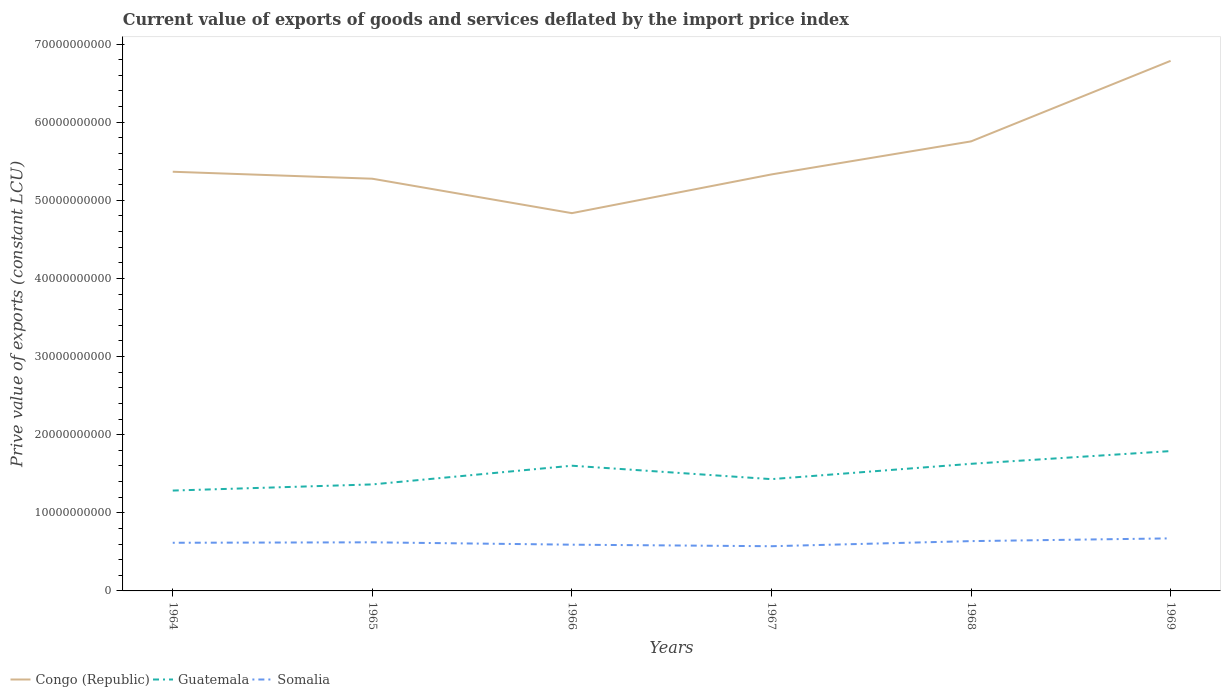Is the number of lines equal to the number of legend labels?
Offer a terse response. Yes. Across all years, what is the maximum prive value of exports in Somalia?
Keep it short and to the point. 5.72e+09. In which year was the prive value of exports in Congo (Republic) maximum?
Offer a terse response. 1966. What is the total prive value of exports in Congo (Republic) in the graph?
Your answer should be compact. -1.42e+1. What is the difference between the highest and the second highest prive value of exports in Guatemala?
Provide a short and direct response. 5.06e+09. What is the difference between the highest and the lowest prive value of exports in Guatemala?
Your answer should be compact. 3. How many lines are there?
Provide a short and direct response. 3. What is the difference between two consecutive major ticks on the Y-axis?
Provide a short and direct response. 1.00e+1. Are the values on the major ticks of Y-axis written in scientific E-notation?
Your response must be concise. No. Does the graph contain any zero values?
Provide a short and direct response. No. Where does the legend appear in the graph?
Ensure brevity in your answer.  Bottom left. How many legend labels are there?
Your answer should be compact. 3. What is the title of the graph?
Give a very brief answer. Current value of exports of goods and services deflated by the import price index. What is the label or title of the X-axis?
Offer a terse response. Years. What is the label or title of the Y-axis?
Make the answer very short. Prive value of exports (constant LCU). What is the Prive value of exports (constant LCU) of Congo (Republic) in 1964?
Your answer should be compact. 5.37e+1. What is the Prive value of exports (constant LCU) in Guatemala in 1964?
Your response must be concise. 1.28e+1. What is the Prive value of exports (constant LCU) in Somalia in 1964?
Ensure brevity in your answer.  6.16e+09. What is the Prive value of exports (constant LCU) in Congo (Republic) in 1965?
Provide a succinct answer. 5.28e+1. What is the Prive value of exports (constant LCU) in Guatemala in 1965?
Make the answer very short. 1.36e+1. What is the Prive value of exports (constant LCU) in Somalia in 1965?
Your answer should be compact. 6.22e+09. What is the Prive value of exports (constant LCU) in Congo (Republic) in 1966?
Give a very brief answer. 4.84e+1. What is the Prive value of exports (constant LCU) of Guatemala in 1966?
Provide a succinct answer. 1.60e+1. What is the Prive value of exports (constant LCU) in Somalia in 1966?
Give a very brief answer. 5.92e+09. What is the Prive value of exports (constant LCU) in Congo (Republic) in 1967?
Offer a very short reply. 5.33e+1. What is the Prive value of exports (constant LCU) in Guatemala in 1967?
Make the answer very short. 1.43e+1. What is the Prive value of exports (constant LCU) of Somalia in 1967?
Your response must be concise. 5.72e+09. What is the Prive value of exports (constant LCU) in Congo (Republic) in 1968?
Offer a very short reply. 5.75e+1. What is the Prive value of exports (constant LCU) of Guatemala in 1968?
Make the answer very short. 1.63e+1. What is the Prive value of exports (constant LCU) in Somalia in 1968?
Offer a very short reply. 6.37e+09. What is the Prive value of exports (constant LCU) of Congo (Republic) in 1969?
Your response must be concise. 6.78e+1. What is the Prive value of exports (constant LCU) of Guatemala in 1969?
Offer a very short reply. 1.79e+1. What is the Prive value of exports (constant LCU) of Somalia in 1969?
Your answer should be very brief. 6.73e+09. Across all years, what is the maximum Prive value of exports (constant LCU) of Congo (Republic)?
Ensure brevity in your answer.  6.78e+1. Across all years, what is the maximum Prive value of exports (constant LCU) in Guatemala?
Ensure brevity in your answer.  1.79e+1. Across all years, what is the maximum Prive value of exports (constant LCU) in Somalia?
Give a very brief answer. 6.73e+09. Across all years, what is the minimum Prive value of exports (constant LCU) in Congo (Republic)?
Offer a very short reply. 4.84e+1. Across all years, what is the minimum Prive value of exports (constant LCU) in Guatemala?
Your answer should be very brief. 1.28e+1. Across all years, what is the minimum Prive value of exports (constant LCU) in Somalia?
Provide a succinct answer. 5.72e+09. What is the total Prive value of exports (constant LCU) of Congo (Republic) in the graph?
Offer a very short reply. 3.33e+11. What is the total Prive value of exports (constant LCU) of Guatemala in the graph?
Your response must be concise. 9.10e+1. What is the total Prive value of exports (constant LCU) in Somalia in the graph?
Make the answer very short. 3.71e+1. What is the difference between the Prive value of exports (constant LCU) in Congo (Republic) in 1964 and that in 1965?
Provide a short and direct response. 8.94e+08. What is the difference between the Prive value of exports (constant LCU) of Guatemala in 1964 and that in 1965?
Provide a short and direct response. -7.87e+08. What is the difference between the Prive value of exports (constant LCU) of Somalia in 1964 and that in 1965?
Your answer should be very brief. -5.68e+07. What is the difference between the Prive value of exports (constant LCU) of Congo (Republic) in 1964 and that in 1966?
Provide a succinct answer. 5.30e+09. What is the difference between the Prive value of exports (constant LCU) in Guatemala in 1964 and that in 1966?
Provide a succinct answer. -3.18e+09. What is the difference between the Prive value of exports (constant LCU) of Somalia in 1964 and that in 1966?
Offer a very short reply. 2.45e+08. What is the difference between the Prive value of exports (constant LCU) in Congo (Republic) in 1964 and that in 1967?
Keep it short and to the point. 3.43e+08. What is the difference between the Prive value of exports (constant LCU) of Guatemala in 1964 and that in 1967?
Ensure brevity in your answer.  -1.46e+09. What is the difference between the Prive value of exports (constant LCU) of Somalia in 1964 and that in 1967?
Provide a short and direct response. 4.42e+08. What is the difference between the Prive value of exports (constant LCU) in Congo (Republic) in 1964 and that in 1968?
Offer a terse response. -3.89e+09. What is the difference between the Prive value of exports (constant LCU) of Guatemala in 1964 and that in 1968?
Your answer should be compact. -3.42e+09. What is the difference between the Prive value of exports (constant LCU) of Somalia in 1964 and that in 1968?
Your answer should be very brief. -2.11e+08. What is the difference between the Prive value of exports (constant LCU) in Congo (Republic) in 1964 and that in 1969?
Your response must be concise. -1.42e+1. What is the difference between the Prive value of exports (constant LCU) in Guatemala in 1964 and that in 1969?
Ensure brevity in your answer.  -5.06e+09. What is the difference between the Prive value of exports (constant LCU) of Somalia in 1964 and that in 1969?
Offer a terse response. -5.62e+08. What is the difference between the Prive value of exports (constant LCU) in Congo (Republic) in 1965 and that in 1966?
Your response must be concise. 4.41e+09. What is the difference between the Prive value of exports (constant LCU) in Guatemala in 1965 and that in 1966?
Ensure brevity in your answer.  -2.39e+09. What is the difference between the Prive value of exports (constant LCU) in Somalia in 1965 and that in 1966?
Provide a succinct answer. 3.02e+08. What is the difference between the Prive value of exports (constant LCU) of Congo (Republic) in 1965 and that in 1967?
Offer a very short reply. -5.51e+08. What is the difference between the Prive value of exports (constant LCU) of Guatemala in 1965 and that in 1967?
Give a very brief answer. -6.75e+08. What is the difference between the Prive value of exports (constant LCU) in Somalia in 1965 and that in 1967?
Your answer should be very brief. 4.99e+08. What is the difference between the Prive value of exports (constant LCU) in Congo (Republic) in 1965 and that in 1968?
Make the answer very short. -4.78e+09. What is the difference between the Prive value of exports (constant LCU) of Guatemala in 1965 and that in 1968?
Provide a succinct answer. -2.64e+09. What is the difference between the Prive value of exports (constant LCU) in Somalia in 1965 and that in 1968?
Provide a succinct answer. -1.54e+08. What is the difference between the Prive value of exports (constant LCU) in Congo (Republic) in 1965 and that in 1969?
Offer a very short reply. -1.51e+1. What is the difference between the Prive value of exports (constant LCU) of Guatemala in 1965 and that in 1969?
Ensure brevity in your answer.  -4.27e+09. What is the difference between the Prive value of exports (constant LCU) of Somalia in 1965 and that in 1969?
Provide a short and direct response. -5.06e+08. What is the difference between the Prive value of exports (constant LCU) in Congo (Republic) in 1966 and that in 1967?
Ensure brevity in your answer.  -4.96e+09. What is the difference between the Prive value of exports (constant LCU) in Guatemala in 1966 and that in 1967?
Offer a terse response. 1.72e+09. What is the difference between the Prive value of exports (constant LCU) in Somalia in 1966 and that in 1967?
Give a very brief answer. 1.97e+08. What is the difference between the Prive value of exports (constant LCU) of Congo (Republic) in 1966 and that in 1968?
Your response must be concise. -9.19e+09. What is the difference between the Prive value of exports (constant LCU) of Guatemala in 1966 and that in 1968?
Make the answer very short. -2.43e+08. What is the difference between the Prive value of exports (constant LCU) in Somalia in 1966 and that in 1968?
Make the answer very short. -4.56e+08. What is the difference between the Prive value of exports (constant LCU) in Congo (Republic) in 1966 and that in 1969?
Your response must be concise. -1.95e+1. What is the difference between the Prive value of exports (constant LCU) in Guatemala in 1966 and that in 1969?
Ensure brevity in your answer.  -1.87e+09. What is the difference between the Prive value of exports (constant LCU) in Somalia in 1966 and that in 1969?
Your answer should be very brief. -8.08e+08. What is the difference between the Prive value of exports (constant LCU) in Congo (Republic) in 1967 and that in 1968?
Your answer should be compact. -4.23e+09. What is the difference between the Prive value of exports (constant LCU) in Guatemala in 1967 and that in 1968?
Provide a short and direct response. -1.96e+09. What is the difference between the Prive value of exports (constant LCU) of Somalia in 1967 and that in 1968?
Your answer should be very brief. -6.53e+08. What is the difference between the Prive value of exports (constant LCU) in Congo (Republic) in 1967 and that in 1969?
Offer a very short reply. -1.45e+1. What is the difference between the Prive value of exports (constant LCU) in Guatemala in 1967 and that in 1969?
Give a very brief answer. -3.59e+09. What is the difference between the Prive value of exports (constant LCU) in Somalia in 1967 and that in 1969?
Keep it short and to the point. -1.00e+09. What is the difference between the Prive value of exports (constant LCU) of Congo (Republic) in 1968 and that in 1969?
Provide a succinct answer. -1.03e+1. What is the difference between the Prive value of exports (constant LCU) of Guatemala in 1968 and that in 1969?
Make the answer very short. -1.63e+09. What is the difference between the Prive value of exports (constant LCU) of Somalia in 1968 and that in 1969?
Offer a terse response. -3.52e+08. What is the difference between the Prive value of exports (constant LCU) in Congo (Republic) in 1964 and the Prive value of exports (constant LCU) in Guatemala in 1965?
Keep it short and to the point. 4.00e+1. What is the difference between the Prive value of exports (constant LCU) of Congo (Republic) in 1964 and the Prive value of exports (constant LCU) of Somalia in 1965?
Your answer should be compact. 4.74e+1. What is the difference between the Prive value of exports (constant LCU) in Guatemala in 1964 and the Prive value of exports (constant LCU) in Somalia in 1965?
Keep it short and to the point. 6.63e+09. What is the difference between the Prive value of exports (constant LCU) in Congo (Republic) in 1964 and the Prive value of exports (constant LCU) in Guatemala in 1966?
Offer a terse response. 3.76e+1. What is the difference between the Prive value of exports (constant LCU) in Congo (Republic) in 1964 and the Prive value of exports (constant LCU) in Somalia in 1966?
Your answer should be compact. 4.77e+1. What is the difference between the Prive value of exports (constant LCU) of Guatemala in 1964 and the Prive value of exports (constant LCU) of Somalia in 1966?
Make the answer very short. 6.93e+09. What is the difference between the Prive value of exports (constant LCU) in Congo (Republic) in 1964 and the Prive value of exports (constant LCU) in Guatemala in 1967?
Your answer should be very brief. 3.93e+1. What is the difference between the Prive value of exports (constant LCU) of Congo (Republic) in 1964 and the Prive value of exports (constant LCU) of Somalia in 1967?
Offer a very short reply. 4.79e+1. What is the difference between the Prive value of exports (constant LCU) of Guatemala in 1964 and the Prive value of exports (constant LCU) of Somalia in 1967?
Your answer should be compact. 7.12e+09. What is the difference between the Prive value of exports (constant LCU) in Congo (Republic) in 1964 and the Prive value of exports (constant LCU) in Guatemala in 1968?
Offer a very short reply. 3.74e+1. What is the difference between the Prive value of exports (constant LCU) in Congo (Republic) in 1964 and the Prive value of exports (constant LCU) in Somalia in 1968?
Ensure brevity in your answer.  4.73e+1. What is the difference between the Prive value of exports (constant LCU) of Guatemala in 1964 and the Prive value of exports (constant LCU) of Somalia in 1968?
Provide a succinct answer. 6.47e+09. What is the difference between the Prive value of exports (constant LCU) of Congo (Republic) in 1964 and the Prive value of exports (constant LCU) of Guatemala in 1969?
Provide a succinct answer. 3.58e+1. What is the difference between the Prive value of exports (constant LCU) in Congo (Republic) in 1964 and the Prive value of exports (constant LCU) in Somalia in 1969?
Ensure brevity in your answer.  4.69e+1. What is the difference between the Prive value of exports (constant LCU) of Guatemala in 1964 and the Prive value of exports (constant LCU) of Somalia in 1969?
Your answer should be very brief. 6.12e+09. What is the difference between the Prive value of exports (constant LCU) in Congo (Republic) in 1965 and the Prive value of exports (constant LCU) in Guatemala in 1966?
Provide a short and direct response. 3.67e+1. What is the difference between the Prive value of exports (constant LCU) in Congo (Republic) in 1965 and the Prive value of exports (constant LCU) in Somalia in 1966?
Ensure brevity in your answer.  4.68e+1. What is the difference between the Prive value of exports (constant LCU) in Guatemala in 1965 and the Prive value of exports (constant LCU) in Somalia in 1966?
Give a very brief answer. 7.71e+09. What is the difference between the Prive value of exports (constant LCU) in Congo (Republic) in 1965 and the Prive value of exports (constant LCU) in Guatemala in 1967?
Offer a very short reply. 3.85e+1. What is the difference between the Prive value of exports (constant LCU) in Congo (Republic) in 1965 and the Prive value of exports (constant LCU) in Somalia in 1967?
Provide a short and direct response. 4.70e+1. What is the difference between the Prive value of exports (constant LCU) of Guatemala in 1965 and the Prive value of exports (constant LCU) of Somalia in 1967?
Provide a short and direct response. 7.91e+09. What is the difference between the Prive value of exports (constant LCU) in Congo (Republic) in 1965 and the Prive value of exports (constant LCU) in Guatemala in 1968?
Your response must be concise. 3.65e+1. What is the difference between the Prive value of exports (constant LCU) of Congo (Republic) in 1965 and the Prive value of exports (constant LCU) of Somalia in 1968?
Your answer should be compact. 4.64e+1. What is the difference between the Prive value of exports (constant LCU) of Guatemala in 1965 and the Prive value of exports (constant LCU) of Somalia in 1968?
Provide a succinct answer. 7.26e+09. What is the difference between the Prive value of exports (constant LCU) of Congo (Republic) in 1965 and the Prive value of exports (constant LCU) of Guatemala in 1969?
Your answer should be compact. 3.49e+1. What is the difference between the Prive value of exports (constant LCU) of Congo (Republic) in 1965 and the Prive value of exports (constant LCU) of Somalia in 1969?
Your answer should be compact. 4.60e+1. What is the difference between the Prive value of exports (constant LCU) of Guatemala in 1965 and the Prive value of exports (constant LCU) of Somalia in 1969?
Offer a terse response. 6.91e+09. What is the difference between the Prive value of exports (constant LCU) in Congo (Republic) in 1966 and the Prive value of exports (constant LCU) in Guatemala in 1967?
Ensure brevity in your answer.  3.40e+1. What is the difference between the Prive value of exports (constant LCU) of Congo (Republic) in 1966 and the Prive value of exports (constant LCU) of Somalia in 1967?
Ensure brevity in your answer.  4.26e+1. What is the difference between the Prive value of exports (constant LCU) in Guatemala in 1966 and the Prive value of exports (constant LCU) in Somalia in 1967?
Offer a terse response. 1.03e+1. What is the difference between the Prive value of exports (constant LCU) of Congo (Republic) in 1966 and the Prive value of exports (constant LCU) of Guatemala in 1968?
Offer a terse response. 3.21e+1. What is the difference between the Prive value of exports (constant LCU) of Congo (Republic) in 1966 and the Prive value of exports (constant LCU) of Somalia in 1968?
Offer a terse response. 4.20e+1. What is the difference between the Prive value of exports (constant LCU) in Guatemala in 1966 and the Prive value of exports (constant LCU) in Somalia in 1968?
Your answer should be very brief. 9.65e+09. What is the difference between the Prive value of exports (constant LCU) of Congo (Republic) in 1966 and the Prive value of exports (constant LCU) of Guatemala in 1969?
Keep it short and to the point. 3.05e+1. What is the difference between the Prive value of exports (constant LCU) of Congo (Republic) in 1966 and the Prive value of exports (constant LCU) of Somalia in 1969?
Make the answer very short. 4.16e+1. What is the difference between the Prive value of exports (constant LCU) in Guatemala in 1966 and the Prive value of exports (constant LCU) in Somalia in 1969?
Your answer should be very brief. 9.30e+09. What is the difference between the Prive value of exports (constant LCU) of Congo (Republic) in 1967 and the Prive value of exports (constant LCU) of Guatemala in 1968?
Provide a short and direct response. 3.70e+1. What is the difference between the Prive value of exports (constant LCU) in Congo (Republic) in 1967 and the Prive value of exports (constant LCU) in Somalia in 1968?
Ensure brevity in your answer.  4.69e+1. What is the difference between the Prive value of exports (constant LCU) of Guatemala in 1967 and the Prive value of exports (constant LCU) of Somalia in 1968?
Ensure brevity in your answer.  7.93e+09. What is the difference between the Prive value of exports (constant LCU) in Congo (Republic) in 1967 and the Prive value of exports (constant LCU) in Guatemala in 1969?
Make the answer very short. 3.54e+1. What is the difference between the Prive value of exports (constant LCU) of Congo (Republic) in 1967 and the Prive value of exports (constant LCU) of Somalia in 1969?
Offer a very short reply. 4.66e+1. What is the difference between the Prive value of exports (constant LCU) in Guatemala in 1967 and the Prive value of exports (constant LCU) in Somalia in 1969?
Make the answer very short. 7.58e+09. What is the difference between the Prive value of exports (constant LCU) in Congo (Republic) in 1968 and the Prive value of exports (constant LCU) in Guatemala in 1969?
Make the answer very short. 3.96e+1. What is the difference between the Prive value of exports (constant LCU) of Congo (Republic) in 1968 and the Prive value of exports (constant LCU) of Somalia in 1969?
Ensure brevity in your answer.  5.08e+1. What is the difference between the Prive value of exports (constant LCU) in Guatemala in 1968 and the Prive value of exports (constant LCU) in Somalia in 1969?
Your answer should be very brief. 9.54e+09. What is the average Prive value of exports (constant LCU) of Congo (Republic) per year?
Offer a terse response. 5.56e+1. What is the average Prive value of exports (constant LCU) of Guatemala per year?
Give a very brief answer. 1.52e+1. What is the average Prive value of exports (constant LCU) in Somalia per year?
Offer a very short reply. 6.19e+09. In the year 1964, what is the difference between the Prive value of exports (constant LCU) of Congo (Republic) and Prive value of exports (constant LCU) of Guatemala?
Provide a short and direct response. 4.08e+1. In the year 1964, what is the difference between the Prive value of exports (constant LCU) of Congo (Republic) and Prive value of exports (constant LCU) of Somalia?
Give a very brief answer. 4.75e+1. In the year 1964, what is the difference between the Prive value of exports (constant LCU) in Guatemala and Prive value of exports (constant LCU) in Somalia?
Make the answer very short. 6.68e+09. In the year 1965, what is the difference between the Prive value of exports (constant LCU) of Congo (Republic) and Prive value of exports (constant LCU) of Guatemala?
Provide a succinct answer. 3.91e+1. In the year 1965, what is the difference between the Prive value of exports (constant LCU) in Congo (Republic) and Prive value of exports (constant LCU) in Somalia?
Your response must be concise. 4.65e+1. In the year 1965, what is the difference between the Prive value of exports (constant LCU) of Guatemala and Prive value of exports (constant LCU) of Somalia?
Provide a succinct answer. 7.41e+09. In the year 1966, what is the difference between the Prive value of exports (constant LCU) of Congo (Republic) and Prive value of exports (constant LCU) of Guatemala?
Your answer should be compact. 3.23e+1. In the year 1966, what is the difference between the Prive value of exports (constant LCU) of Congo (Republic) and Prive value of exports (constant LCU) of Somalia?
Offer a terse response. 4.24e+1. In the year 1966, what is the difference between the Prive value of exports (constant LCU) in Guatemala and Prive value of exports (constant LCU) in Somalia?
Keep it short and to the point. 1.01e+1. In the year 1967, what is the difference between the Prive value of exports (constant LCU) of Congo (Republic) and Prive value of exports (constant LCU) of Guatemala?
Your answer should be compact. 3.90e+1. In the year 1967, what is the difference between the Prive value of exports (constant LCU) of Congo (Republic) and Prive value of exports (constant LCU) of Somalia?
Make the answer very short. 4.76e+1. In the year 1967, what is the difference between the Prive value of exports (constant LCU) in Guatemala and Prive value of exports (constant LCU) in Somalia?
Offer a very short reply. 8.59e+09. In the year 1968, what is the difference between the Prive value of exports (constant LCU) of Congo (Republic) and Prive value of exports (constant LCU) of Guatemala?
Make the answer very short. 4.13e+1. In the year 1968, what is the difference between the Prive value of exports (constant LCU) of Congo (Republic) and Prive value of exports (constant LCU) of Somalia?
Make the answer very short. 5.12e+1. In the year 1968, what is the difference between the Prive value of exports (constant LCU) in Guatemala and Prive value of exports (constant LCU) in Somalia?
Make the answer very short. 9.90e+09. In the year 1969, what is the difference between the Prive value of exports (constant LCU) of Congo (Republic) and Prive value of exports (constant LCU) of Guatemala?
Offer a very short reply. 4.99e+1. In the year 1969, what is the difference between the Prive value of exports (constant LCU) of Congo (Republic) and Prive value of exports (constant LCU) of Somalia?
Keep it short and to the point. 6.11e+1. In the year 1969, what is the difference between the Prive value of exports (constant LCU) in Guatemala and Prive value of exports (constant LCU) in Somalia?
Your answer should be compact. 1.12e+1. What is the ratio of the Prive value of exports (constant LCU) of Congo (Republic) in 1964 to that in 1965?
Your answer should be very brief. 1.02. What is the ratio of the Prive value of exports (constant LCU) in Guatemala in 1964 to that in 1965?
Give a very brief answer. 0.94. What is the ratio of the Prive value of exports (constant LCU) of Somalia in 1964 to that in 1965?
Give a very brief answer. 0.99. What is the ratio of the Prive value of exports (constant LCU) of Congo (Republic) in 1964 to that in 1966?
Make the answer very short. 1.11. What is the ratio of the Prive value of exports (constant LCU) in Guatemala in 1964 to that in 1966?
Provide a succinct answer. 0.8. What is the ratio of the Prive value of exports (constant LCU) of Somalia in 1964 to that in 1966?
Keep it short and to the point. 1.04. What is the ratio of the Prive value of exports (constant LCU) of Congo (Republic) in 1964 to that in 1967?
Your answer should be very brief. 1.01. What is the ratio of the Prive value of exports (constant LCU) in Guatemala in 1964 to that in 1967?
Provide a succinct answer. 0.9. What is the ratio of the Prive value of exports (constant LCU) of Somalia in 1964 to that in 1967?
Make the answer very short. 1.08. What is the ratio of the Prive value of exports (constant LCU) of Congo (Republic) in 1964 to that in 1968?
Provide a short and direct response. 0.93. What is the ratio of the Prive value of exports (constant LCU) in Guatemala in 1964 to that in 1968?
Provide a succinct answer. 0.79. What is the ratio of the Prive value of exports (constant LCU) of Somalia in 1964 to that in 1968?
Provide a succinct answer. 0.97. What is the ratio of the Prive value of exports (constant LCU) of Congo (Republic) in 1964 to that in 1969?
Keep it short and to the point. 0.79. What is the ratio of the Prive value of exports (constant LCU) in Guatemala in 1964 to that in 1969?
Your answer should be very brief. 0.72. What is the ratio of the Prive value of exports (constant LCU) of Somalia in 1964 to that in 1969?
Provide a succinct answer. 0.92. What is the ratio of the Prive value of exports (constant LCU) in Congo (Republic) in 1965 to that in 1966?
Your answer should be very brief. 1.09. What is the ratio of the Prive value of exports (constant LCU) of Guatemala in 1965 to that in 1966?
Your response must be concise. 0.85. What is the ratio of the Prive value of exports (constant LCU) in Somalia in 1965 to that in 1966?
Your response must be concise. 1.05. What is the ratio of the Prive value of exports (constant LCU) of Guatemala in 1965 to that in 1967?
Offer a terse response. 0.95. What is the ratio of the Prive value of exports (constant LCU) of Somalia in 1965 to that in 1967?
Your answer should be very brief. 1.09. What is the ratio of the Prive value of exports (constant LCU) in Congo (Republic) in 1965 to that in 1968?
Your answer should be very brief. 0.92. What is the ratio of the Prive value of exports (constant LCU) of Guatemala in 1965 to that in 1968?
Give a very brief answer. 0.84. What is the ratio of the Prive value of exports (constant LCU) of Somalia in 1965 to that in 1968?
Offer a very short reply. 0.98. What is the ratio of the Prive value of exports (constant LCU) in Congo (Republic) in 1965 to that in 1969?
Offer a terse response. 0.78. What is the ratio of the Prive value of exports (constant LCU) in Guatemala in 1965 to that in 1969?
Ensure brevity in your answer.  0.76. What is the ratio of the Prive value of exports (constant LCU) in Somalia in 1965 to that in 1969?
Offer a terse response. 0.92. What is the ratio of the Prive value of exports (constant LCU) of Congo (Republic) in 1966 to that in 1967?
Your answer should be compact. 0.91. What is the ratio of the Prive value of exports (constant LCU) in Guatemala in 1966 to that in 1967?
Your answer should be compact. 1.12. What is the ratio of the Prive value of exports (constant LCU) of Somalia in 1966 to that in 1967?
Your answer should be compact. 1.03. What is the ratio of the Prive value of exports (constant LCU) of Congo (Republic) in 1966 to that in 1968?
Offer a very short reply. 0.84. What is the ratio of the Prive value of exports (constant LCU) in Somalia in 1966 to that in 1968?
Your response must be concise. 0.93. What is the ratio of the Prive value of exports (constant LCU) in Congo (Republic) in 1966 to that in 1969?
Your answer should be compact. 0.71. What is the ratio of the Prive value of exports (constant LCU) in Guatemala in 1966 to that in 1969?
Offer a very short reply. 0.9. What is the ratio of the Prive value of exports (constant LCU) in Somalia in 1966 to that in 1969?
Your answer should be very brief. 0.88. What is the ratio of the Prive value of exports (constant LCU) in Congo (Republic) in 1967 to that in 1968?
Make the answer very short. 0.93. What is the ratio of the Prive value of exports (constant LCU) of Guatemala in 1967 to that in 1968?
Provide a succinct answer. 0.88. What is the ratio of the Prive value of exports (constant LCU) of Somalia in 1967 to that in 1968?
Provide a short and direct response. 0.9. What is the ratio of the Prive value of exports (constant LCU) in Congo (Republic) in 1967 to that in 1969?
Your response must be concise. 0.79. What is the ratio of the Prive value of exports (constant LCU) of Guatemala in 1967 to that in 1969?
Make the answer very short. 0.8. What is the ratio of the Prive value of exports (constant LCU) in Somalia in 1967 to that in 1969?
Give a very brief answer. 0.85. What is the ratio of the Prive value of exports (constant LCU) of Congo (Republic) in 1968 to that in 1969?
Ensure brevity in your answer.  0.85. What is the ratio of the Prive value of exports (constant LCU) in Guatemala in 1968 to that in 1969?
Make the answer very short. 0.91. What is the ratio of the Prive value of exports (constant LCU) of Somalia in 1968 to that in 1969?
Offer a terse response. 0.95. What is the difference between the highest and the second highest Prive value of exports (constant LCU) in Congo (Republic)?
Offer a terse response. 1.03e+1. What is the difference between the highest and the second highest Prive value of exports (constant LCU) in Guatemala?
Your response must be concise. 1.63e+09. What is the difference between the highest and the second highest Prive value of exports (constant LCU) in Somalia?
Your answer should be very brief. 3.52e+08. What is the difference between the highest and the lowest Prive value of exports (constant LCU) of Congo (Republic)?
Your answer should be compact. 1.95e+1. What is the difference between the highest and the lowest Prive value of exports (constant LCU) of Guatemala?
Provide a short and direct response. 5.06e+09. What is the difference between the highest and the lowest Prive value of exports (constant LCU) of Somalia?
Your answer should be very brief. 1.00e+09. 